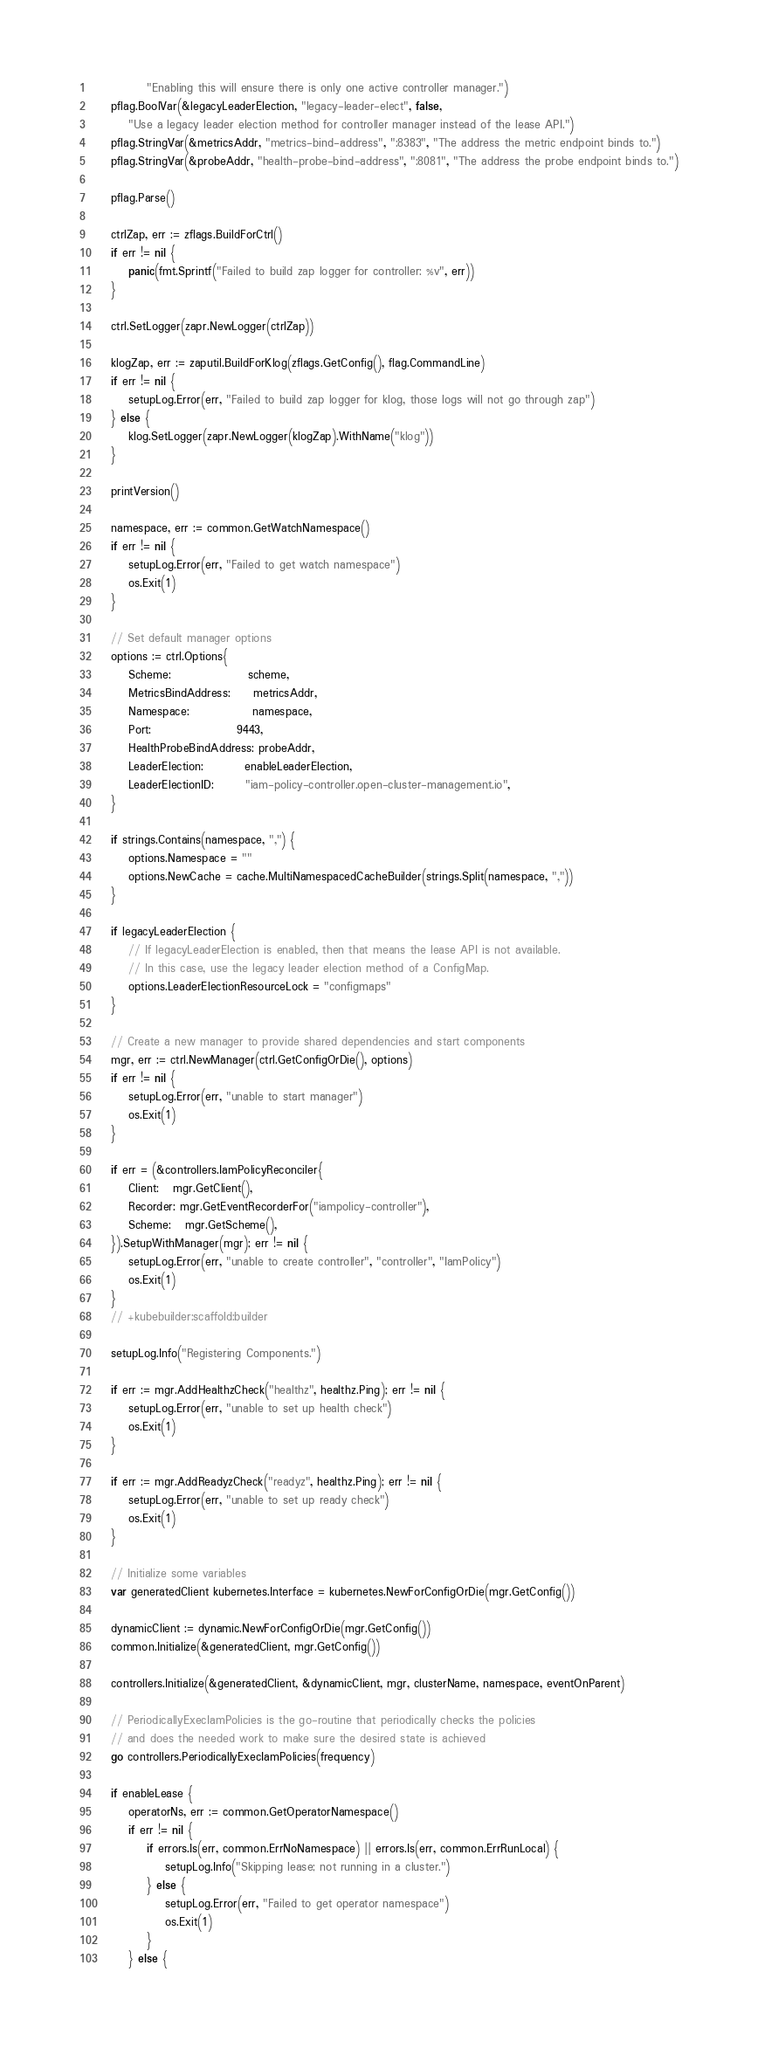<code> <loc_0><loc_0><loc_500><loc_500><_Go_>			"Enabling this will ensure there is only one active controller manager.")
	pflag.BoolVar(&legacyLeaderElection, "legacy-leader-elect", false,
		"Use a legacy leader election method for controller manager instead of the lease API.")
	pflag.StringVar(&metricsAddr, "metrics-bind-address", ":8383", "The address the metric endpoint binds to.")
	pflag.StringVar(&probeAddr, "health-probe-bind-address", ":8081", "The address the probe endpoint binds to.")

	pflag.Parse()

	ctrlZap, err := zflags.BuildForCtrl()
	if err != nil {
		panic(fmt.Sprintf("Failed to build zap logger for controller: %v", err))
	}

	ctrl.SetLogger(zapr.NewLogger(ctrlZap))

	klogZap, err := zaputil.BuildForKlog(zflags.GetConfig(), flag.CommandLine)
	if err != nil {
		setupLog.Error(err, "Failed to build zap logger for klog, those logs will not go through zap")
	} else {
		klog.SetLogger(zapr.NewLogger(klogZap).WithName("klog"))
	}

	printVersion()

	namespace, err := common.GetWatchNamespace()
	if err != nil {
		setupLog.Error(err, "Failed to get watch namespace")
		os.Exit(1)
	}

	// Set default manager options
	options := ctrl.Options{
		Scheme:                 scheme,
		MetricsBindAddress:     metricsAddr,
		Namespace:              namespace,
		Port:                   9443,
		HealthProbeBindAddress: probeAddr,
		LeaderElection:         enableLeaderElection,
		LeaderElectionID:       "iam-policy-controller.open-cluster-management.io",
	}

	if strings.Contains(namespace, ",") {
		options.Namespace = ""
		options.NewCache = cache.MultiNamespacedCacheBuilder(strings.Split(namespace, ","))
	}

	if legacyLeaderElection {
		// If legacyLeaderElection is enabled, then that means the lease API is not available.
		// In this case, use the legacy leader election method of a ConfigMap.
		options.LeaderElectionResourceLock = "configmaps"
	}

	// Create a new manager to provide shared dependencies and start components
	mgr, err := ctrl.NewManager(ctrl.GetConfigOrDie(), options)
	if err != nil {
		setupLog.Error(err, "unable to start manager")
		os.Exit(1)
	}

	if err = (&controllers.IamPolicyReconciler{
		Client:   mgr.GetClient(),
		Recorder: mgr.GetEventRecorderFor("iampolicy-controller"),
		Scheme:   mgr.GetScheme(),
	}).SetupWithManager(mgr); err != nil {
		setupLog.Error(err, "unable to create controller", "controller", "IamPolicy")
		os.Exit(1)
	}
	// +kubebuilder:scaffold:builder

	setupLog.Info("Registering Components.")

	if err := mgr.AddHealthzCheck("healthz", healthz.Ping); err != nil {
		setupLog.Error(err, "unable to set up health check")
		os.Exit(1)
	}

	if err := mgr.AddReadyzCheck("readyz", healthz.Ping); err != nil {
		setupLog.Error(err, "unable to set up ready check")
		os.Exit(1)
	}

	// Initialize some variables
	var generatedClient kubernetes.Interface = kubernetes.NewForConfigOrDie(mgr.GetConfig())

	dynamicClient := dynamic.NewForConfigOrDie(mgr.GetConfig())
	common.Initialize(&generatedClient, mgr.GetConfig())

	controllers.Initialize(&generatedClient, &dynamicClient, mgr, clusterName, namespace, eventOnParent)

	// PeriodicallyExecIamPolicies is the go-routine that periodically checks the policies
	// and does the needed work to make sure the desired state is achieved
	go controllers.PeriodicallyExecIamPolicies(frequency)

	if enableLease {
		operatorNs, err := common.GetOperatorNamespace()
		if err != nil {
			if errors.Is(err, common.ErrNoNamespace) || errors.Is(err, common.ErrRunLocal) {
				setupLog.Info("Skipping lease; not running in a cluster.")
			} else {
				setupLog.Error(err, "Failed to get operator namespace")
				os.Exit(1)
			}
		} else {</code> 